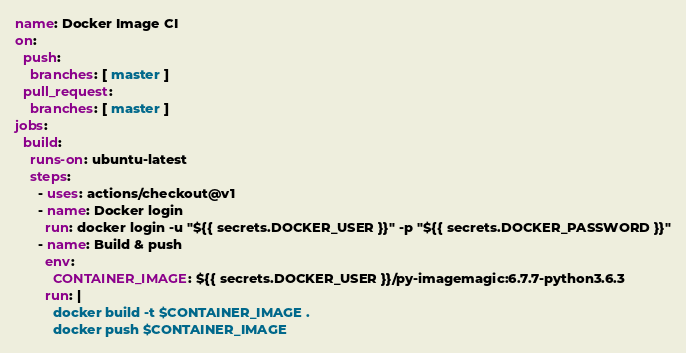Convert code to text. <code><loc_0><loc_0><loc_500><loc_500><_YAML_>name: Docker Image CI
on:
  push:
    branches: [ master ]
  pull_request:
    branches: [ master ]
jobs:
  build:
    runs-on: ubuntu-latest
    steps:
      - uses: actions/checkout@v1
      - name: Docker login
        run: docker login -u "${{ secrets.DOCKER_USER }}" -p "${{ secrets.DOCKER_PASSWORD }}"
      - name: Build & push
        env:
          CONTAINER_IMAGE: ${{ secrets.DOCKER_USER }}/py-imagemagic:6.7.7-python3.6.3
        run: |
          docker build -t $CONTAINER_IMAGE .
          docker push $CONTAINER_IMAGE
</code> 